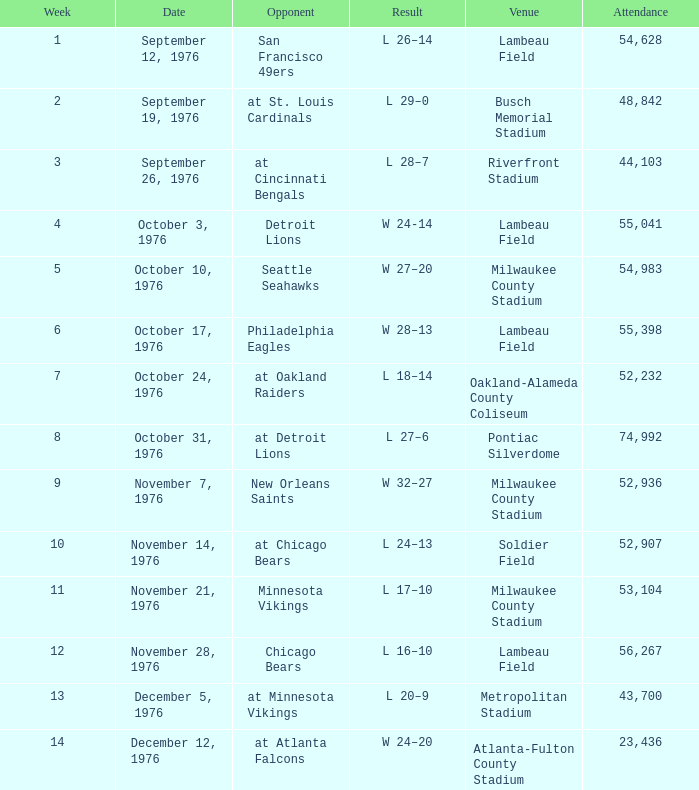What is the average attendance for the game on September 26, 1976? 44103.0. 